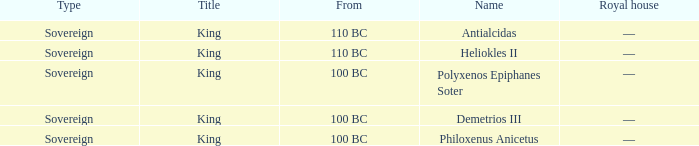When did Philoxenus Anicetus begin to hold power? 100 BC. 